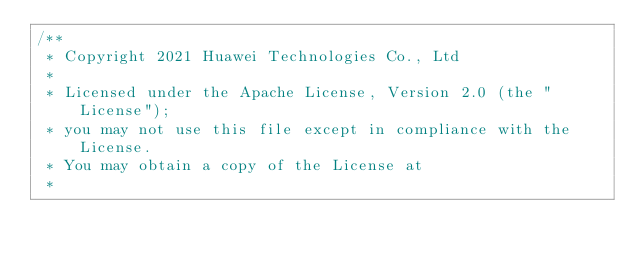Convert code to text. <code><loc_0><loc_0><loc_500><loc_500><_C++_>/**
 * Copyright 2021 Huawei Technologies Co., Ltd
 *
 * Licensed under the Apache License, Version 2.0 (the "License");
 * you may not use this file except in compliance with the License.
 * You may obtain a copy of the License at
 *</code> 